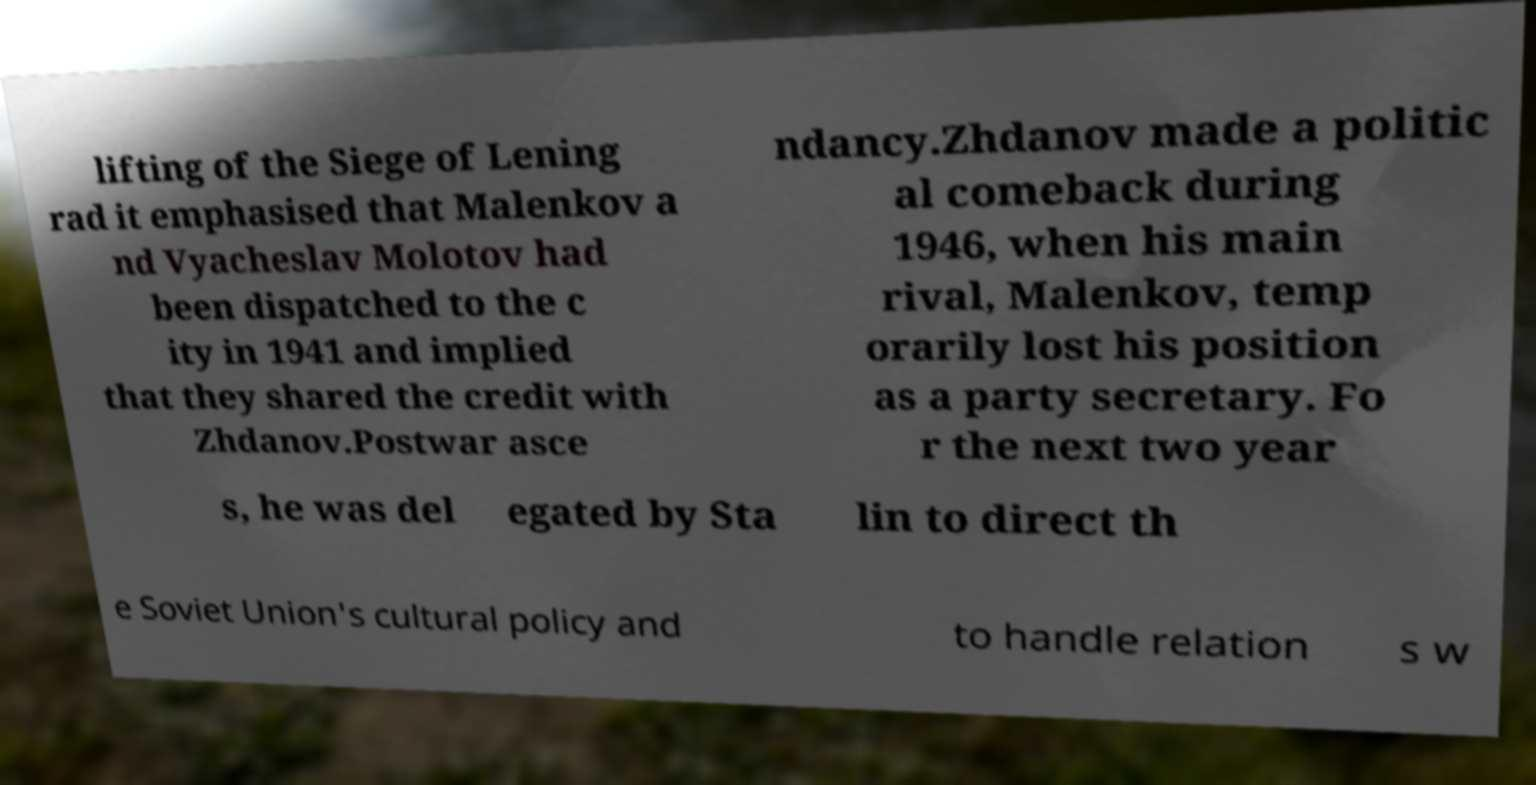Can you accurately transcribe the text from the provided image for me? lifting of the Siege of Lening rad it emphasised that Malenkov a nd Vyacheslav Molotov had been dispatched to the c ity in 1941 and implied that they shared the credit with Zhdanov.Postwar asce ndancy.Zhdanov made a politic al comeback during 1946, when his main rival, Malenkov, temp orarily lost his position as a party secretary. Fo r the next two year s, he was del egated by Sta lin to direct th e Soviet Union's cultural policy and to handle relation s w 